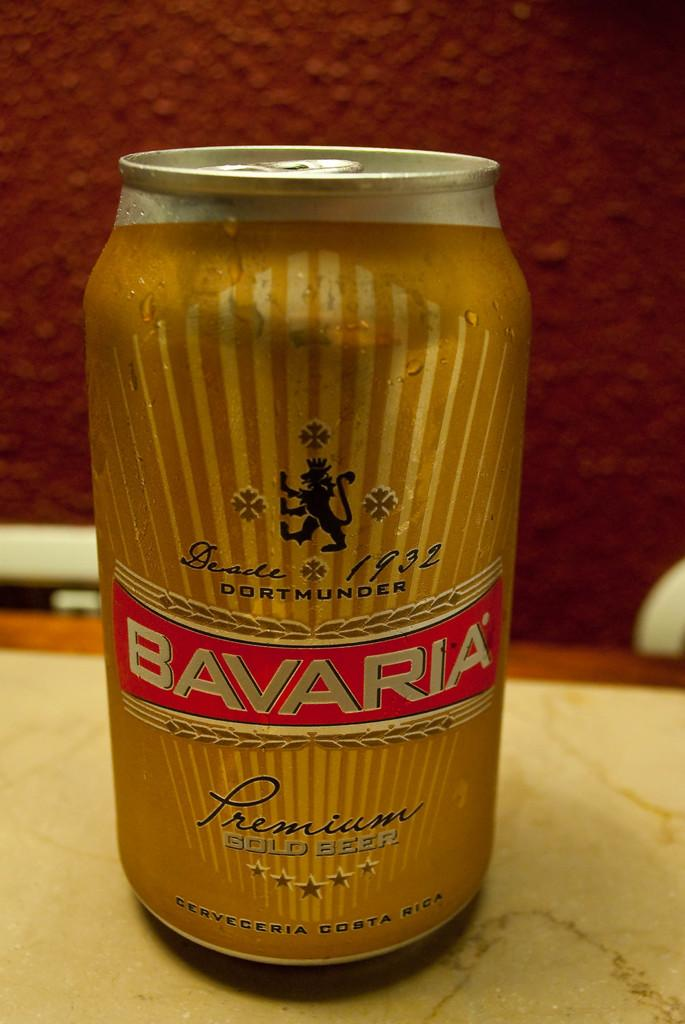<image>
Share a concise interpretation of the image provided. Bavaria is the brand of the canned beverage. 